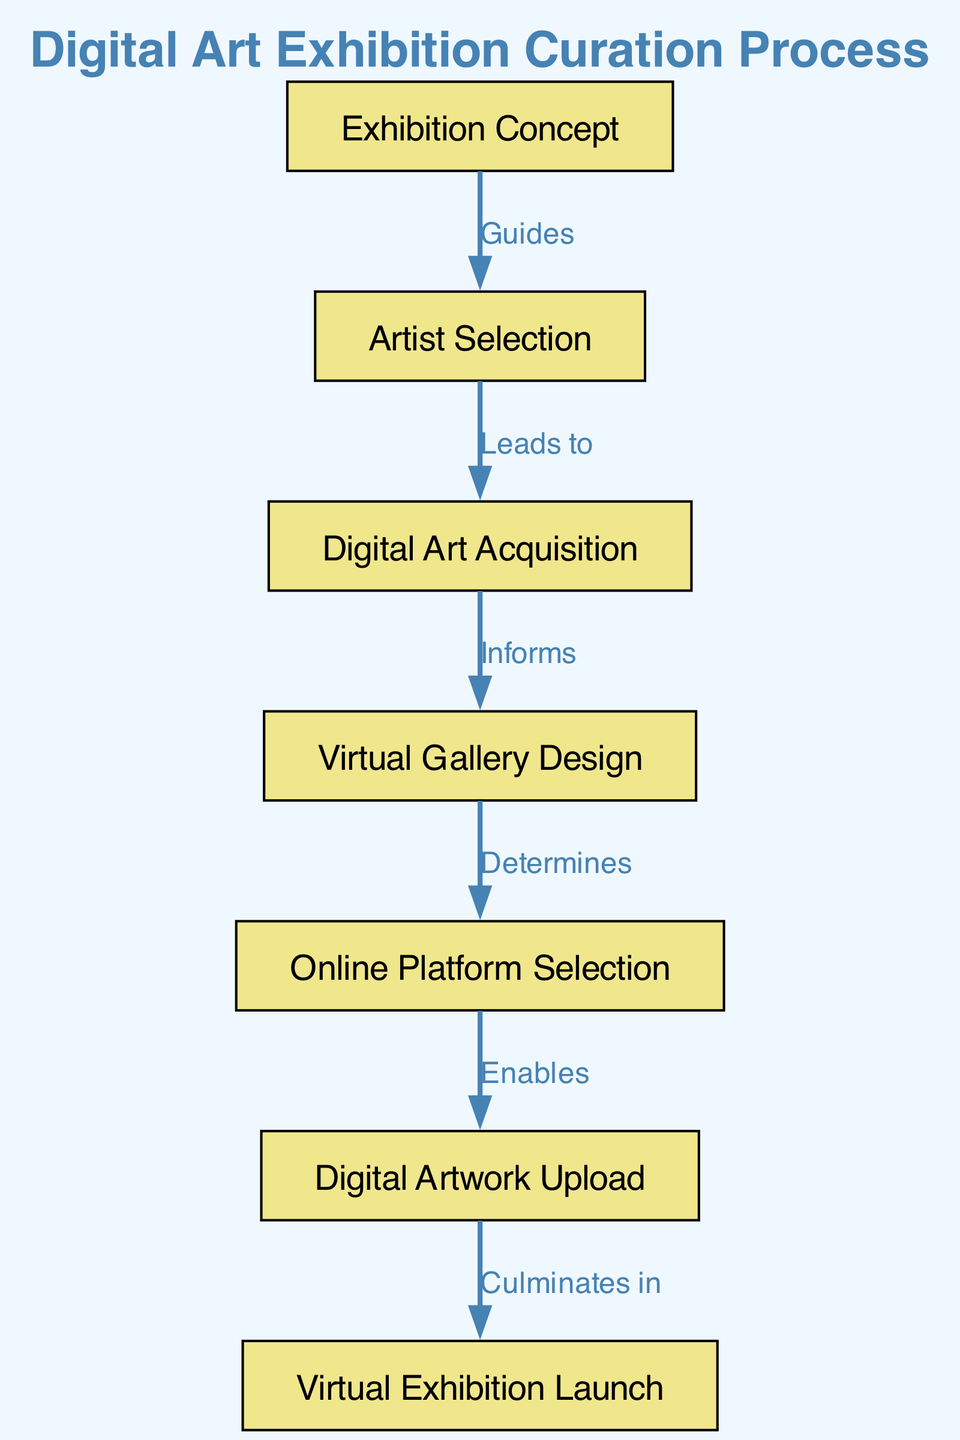What is the first step in the curation process? The first step, represented by the first node in the diagram, is "Exhibition Concept." This node serves as the starting point for the entire curation process.
Answer: Exhibition Concept How many nodes are present in the diagram? To count the total number of nodes, we look at the list provided in the 'nodes' section of the diagram data. There are seven distinct nodes listed.
Answer: 7 What does the node "Artist Selection" guide to? The diagram indicates that "Artist Selection" leads to the next step, which is "Digital Art Acquisition." This is an important connection that shows the progression from selecting artists to acquiring their artwork.
Answer: Digital Art Acquisition Which step informs the "Virtual Gallery Design"? According to the diagram, "Digital Art Acquisition" informs the "Virtual Gallery Design." This suggests that the process of acquiring digital art helps shape the design of the gallery where it will be exhibited.
Answer: Digital Art Acquisition What relationship does "Virtual Gallery Design" have with "Online Platform Selection"? The diagram designates that "Virtual Gallery Design" determines the next step, which is "Online Platform Selection." This indicates that decisions made in the design phase influence the choice of online platforms for exhibiting the artworks.
Answer: Determines After the "Digital Artwork Upload," what is the next step? The flow of the diagram indicates that the step immediately following "Digital Artwork Upload" is "Virtual Exhibition Launch." This is the culmination of all previous processes.
Answer: Virtual Exhibition Launch Which node does "Digital Art Acquisition" lead to? The diagram specifies that "Digital Art Acquisition" leads to "Virtual Gallery Design." This shows a direct and critical path in the curation process.
Answer: Virtual Gallery Design What is the culmination of the entire curation process? The final step represented in the diagram is "Virtual Exhibition Launch," which signifies the completion of the curation process and the public exhibition of the digital art.
Answer: Virtual Exhibition Launch 